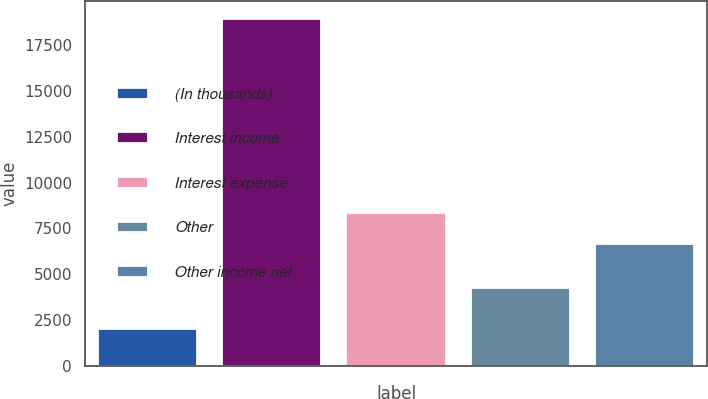Convert chart. <chart><loc_0><loc_0><loc_500><loc_500><bar_chart><fcel>(In thousands)<fcel>Interest income<fcel>Interest expense<fcel>Other<fcel>Other income net<nl><fcel>2017<fcel>18933<fcel>8349.6<fcel>4263<fcel>6658<nl></chart> 